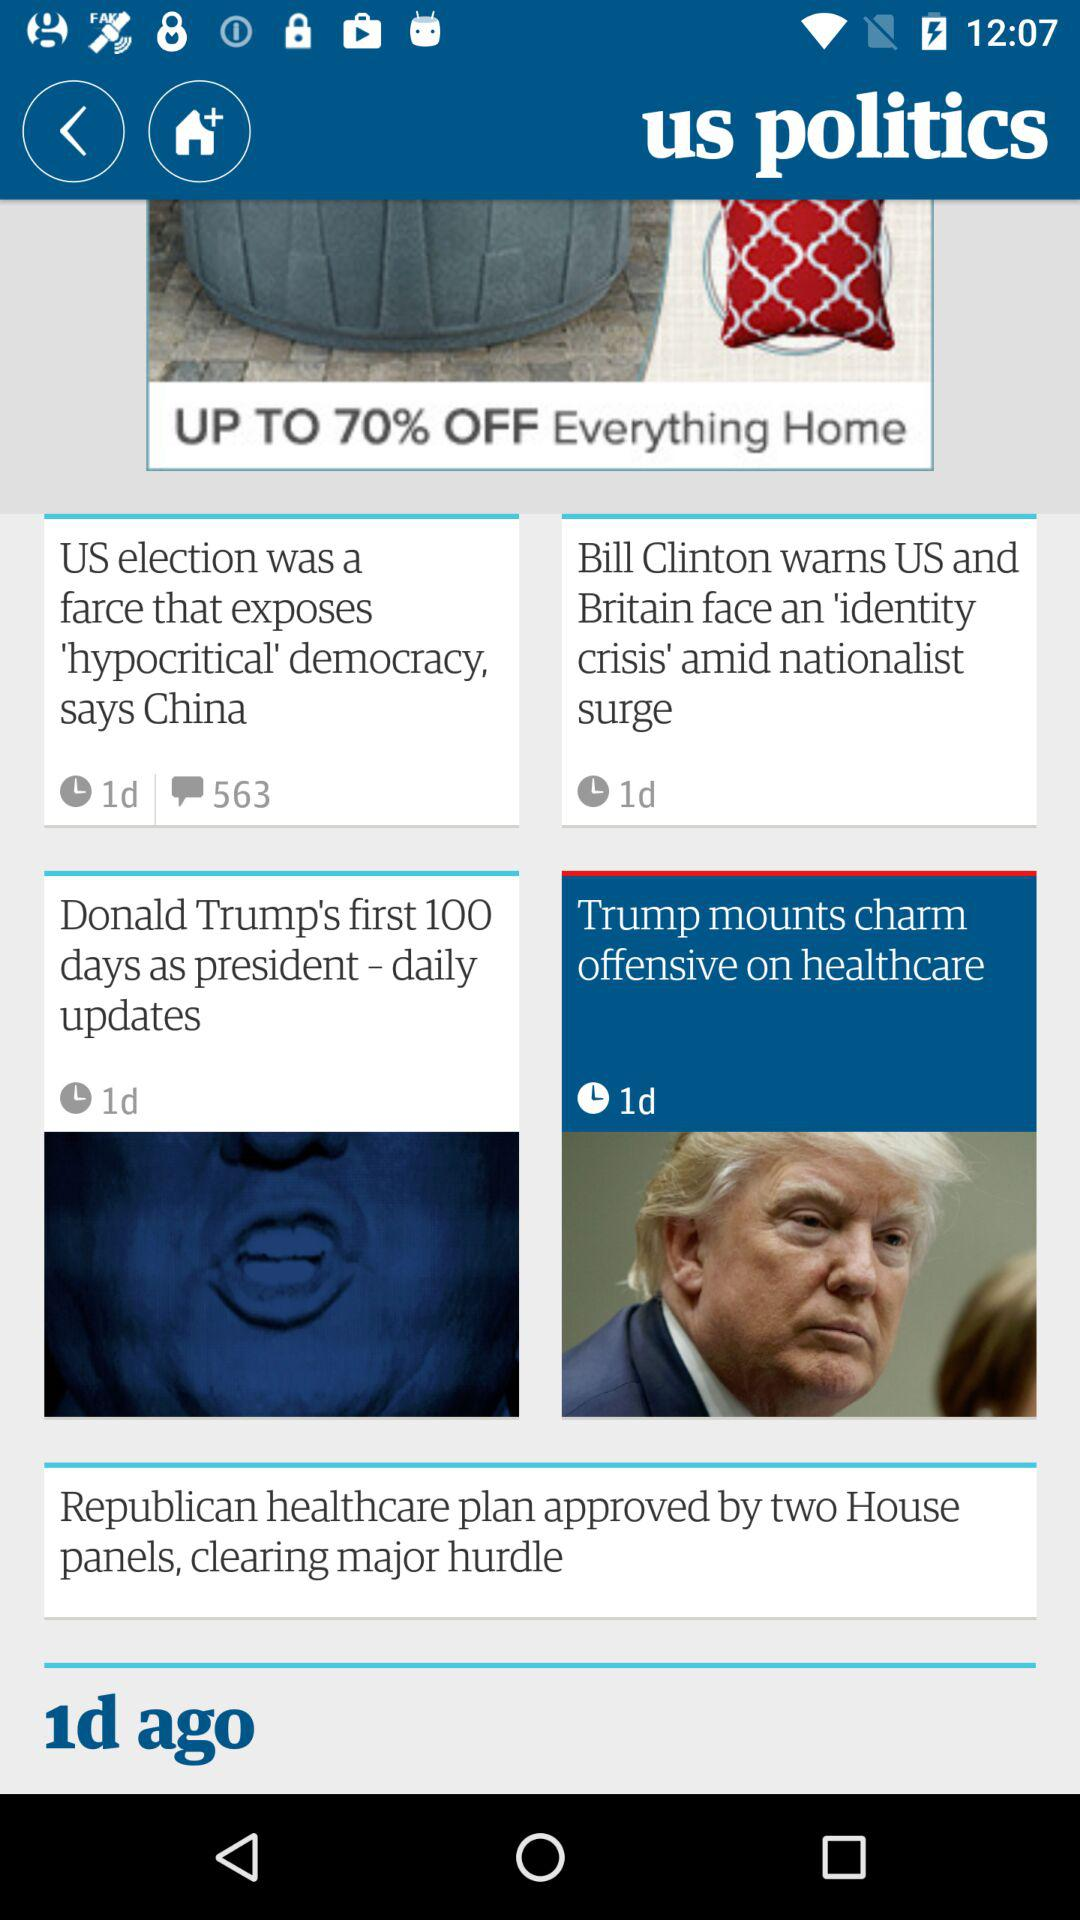What is the number of comments on "US election was a farce that exposes 'hypocritical' democracy, says China"? There are 563 comments. 